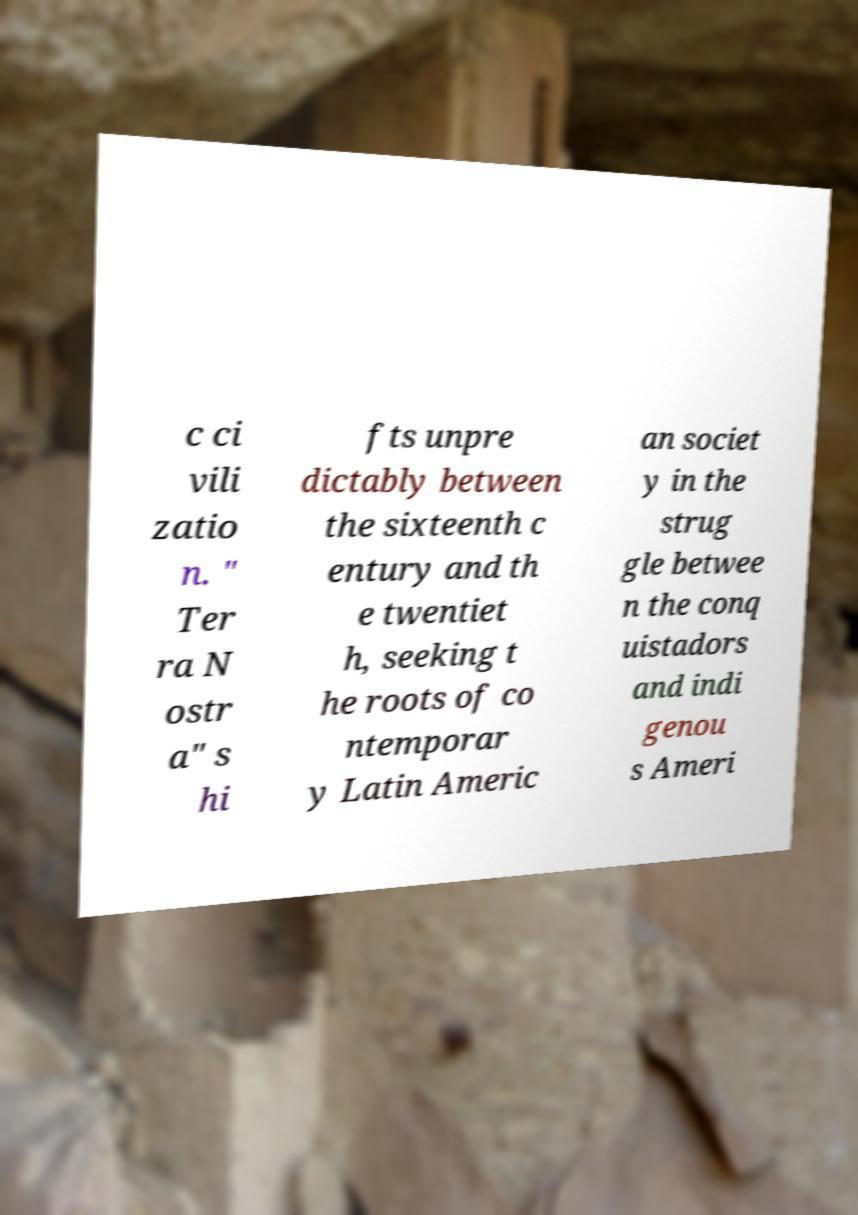I need the written content from this picture converted into text. Can you do that? c ci vili zatio n. " Ter ra N ostr a" s hi fts unpre dictably between the sixteenth c entury and th e twentiet h, seeking t he roots of co ntemporar y Latin Americ an societ y in the strug gle betwee n the conq uistadors and indi genou s Ameri 